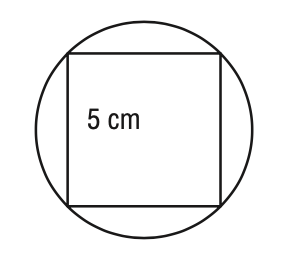Question: A square with 5 - centimeter sides is inscribed in a circle. What is the circumference of the circle? Round your answer to the nearest tenth of a centimeter.
Choices:
A. 11.1
B. 22.2
C. 44.4
D. 88.9
Answer with the letter. Answer: B 